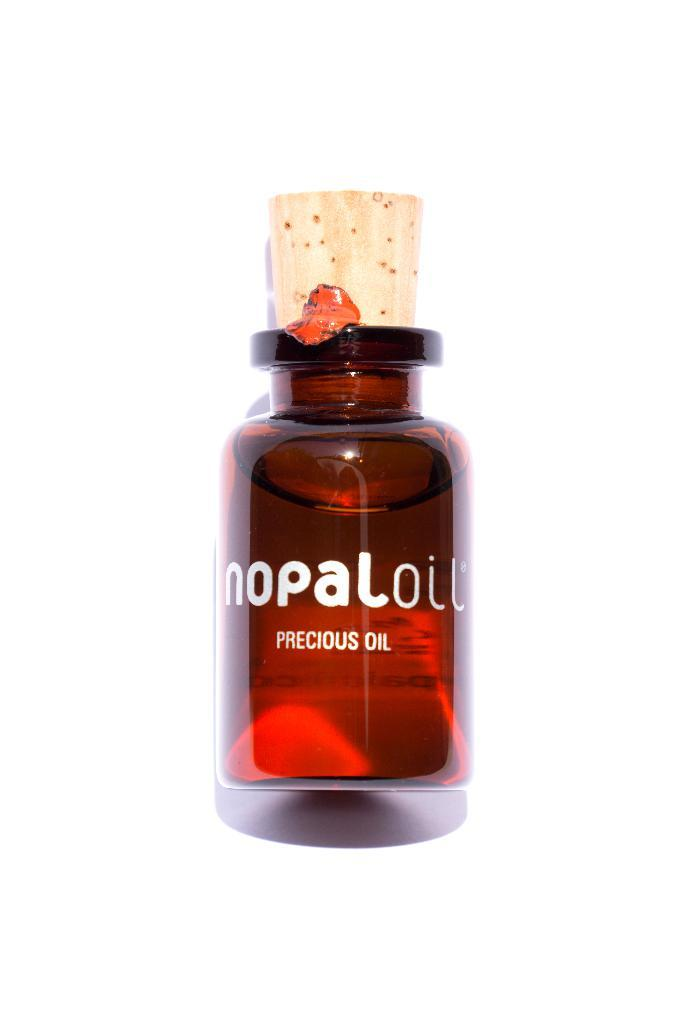Provide a one-sentence caption for the provided image. A small amber colored bottle of Nopal precious oil with cork stopper. 